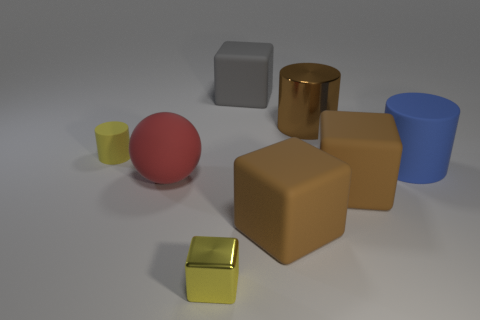What is the shape of the small object that is the same color as the shiny cube?
Provide a succinct answer. Cylinder. What is the size of the block that is the same color as the small cylinder?
Your response must be concise. Small. The big metallic thing that is the same shape as the tiny rubber object is what color?
Offer a very short reply. Brown. What number of objects are the same color as the small rubber cylinder?
Offer a very short reply. 1. Are there more matte blocks that are in front of the tiny yellow rubber cylinder than tiny metallic things?
Offer a very short reply. Yes. There is a rubber cube that is right of the brown cube that is left of the large brown metal thing; what is its color?
Your answer should be very brief. Brown. How many things are either objects behind the large brown shiny cylinder or matte cylinders right of the tiny matte cylinder?
Keep it short and to the point. 2. The big metallic thing is what color?
Keep it short and to the point. Brown. What number of big purple cubes are made of the same material as the gray block?
Your answer should be very brief. 0. Is the number of red matte spheres greater than the number of big blue metallic things?
Offer a terse response. Yes. 